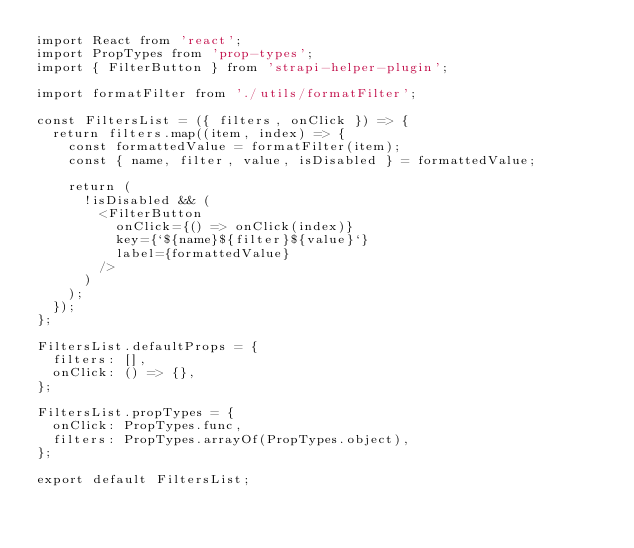Convert code to text. <code><loc_0><loc_0><loc_500><loc_500><_JavaScript_>import React from 'react';
import PropTypes from 'prop-types';
import { FilterButton } from 'strapi-helper-plugin';

import formatFilter from './utils/formatFilter';

const FiltersList = ({ filters, onClick }) => {
  return filters.map((item, index) => {
    const formattedValue = formatFilter(item);
    const { name, filter, value, isDisabled } = formattedValue;

    return (
      !isDisabled && (
        <FilterButton
          onClick={() => onClick(index)}
          key={`${name}${filter}${value}`}
          label={formattedValue}
        />
      )
    );
  });
};

FiltersList.defaultProps = {
  filters: [],
  onClick: () => {},
};

FiltersList.propTypes = {
  onClick: PropTypes.func,
  filters: PropTypes.arrayOf(PropTypes.object),
};

export default FiltersList;
</code> 